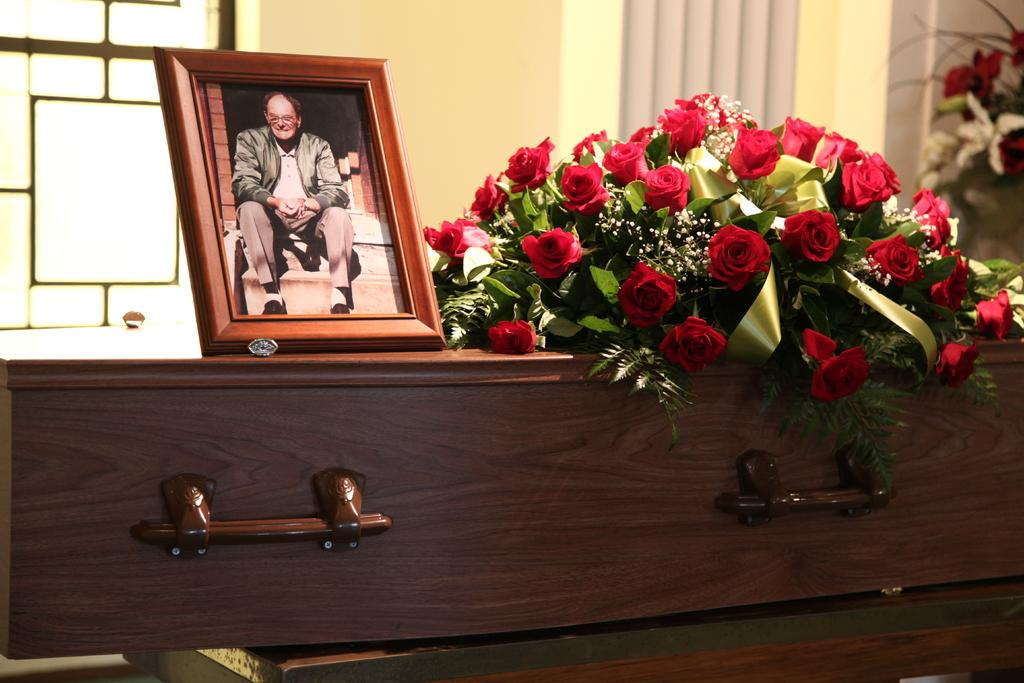What piece of furniture is present in the image? There is a table in the image. What is placed on the table? There is a photograph and a flower bouquet on the table. What type of glue is used to hold the linen in place in the image? There is no linen present in the image, and therefore no glue or any related activity can be observed. 